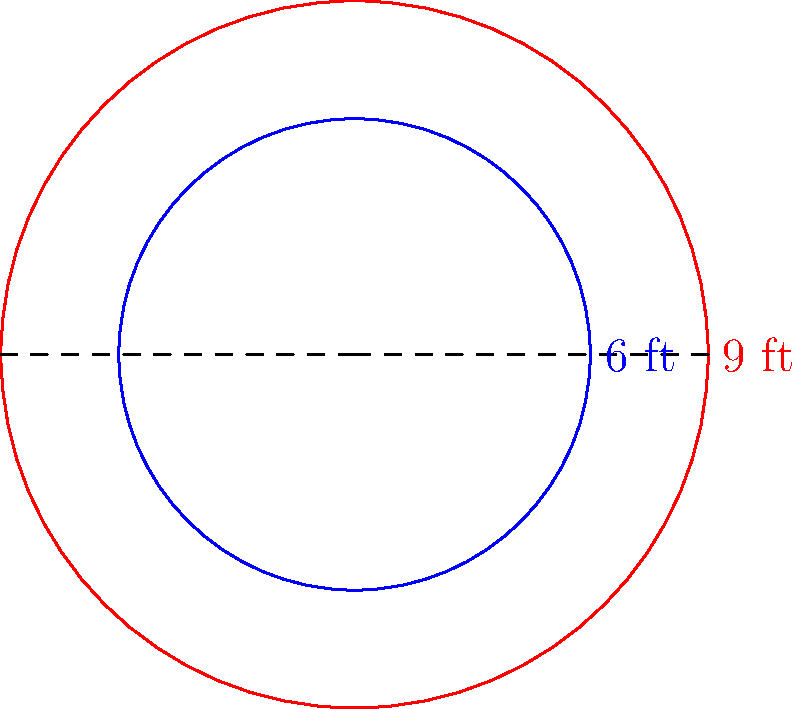In response to evolving public health guidelines, a city is considering expanding its social distancing circles in public spaces from a 6-foot radius to a 9-foot radius. What is the scale factor of this dilation, and how does it affect the area of the social distancing circle? To solve this problem, we'll follow these steps:

1. Calculate the scale factor of the dilation:
   The scale factor is the ratio of the new radius to the original radius.
   Scale factor = New radius / Original radius
   $$ k = \frac{9 \text{ ft}}{6 \text{ ft}} = \frac{3}{2} = 1.5 $$

2. Determine how the dilation affects the area:
   The area of a circle is given by the formula $A = \pi r^2$.
   Let's call the original area $A_1$ and the new area $A_2$.

   $A_1 = \pi (6 \text{ ft})^2 = 36\pi \text{ sq ft}$
   $A_2 = \pi (9 \text{ ft})^2 = 81\pi \text{ sq ft}$

3. Calculate the ratio of the new area to the original area:
   $$ \frac{A_2}{A_1} = \frac{81\pi \text{ sq ft}}{36\pi \text{ sq ft}} = \frac{81}{36} = 2.25 $$

4. Relate this to the scale factor:
   Note that $2.25 = 1.5^2 = k^2$

Therefore, when a circle is dilated by a scale factor $k$, its area is multiplied by $k^2$.
Answer: Scale factor: 1.5; Area increases by a factor of 2.25 (or $1.5^2$) 